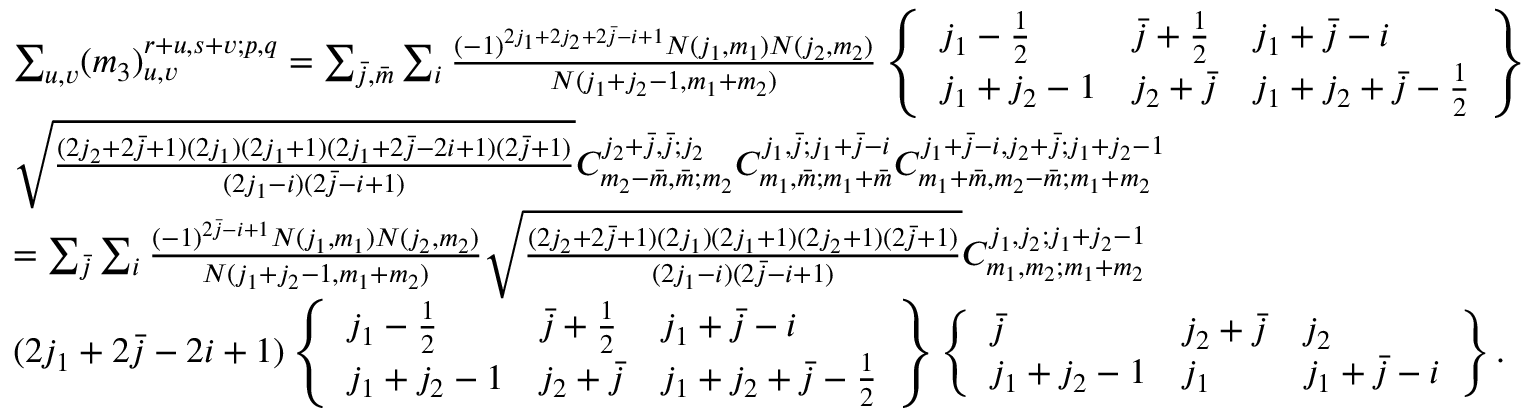Convert formula to latex. <formula><loc_0><loc_0><loc_500><loc_500>\begin{array} { r l } & { \sum _ { u , v } ( m _ { 3 } ) _ { u , v } ^ { r + u , s + v ; p , q } = \sum _ { \bar { j } , \bar { m } } \sum _ { i } \frac { ( - 1 ) ^ { 2 j _ { 1 } + 2 j _ { 2 } + 2 \bar { j } - i + 1 } N ( j _ { 1 } , m _ { 1 } ) N ( j _ { 2 } , m _ { 2 } ) } { N ( j _ { 1 } + j _ { 2 } - 1 , m _ { 1 } + m _ { 2 } ) } \left \{ \begin{array} { l l l } { j _ { 1 } - \frac { 1 } { 2 } } & { \bar { j } + \frac { 1 } { 2 } } & { j _ { 1 } + \bar { j } - i } \\ { j _ { 1 } + j _ { 2 } - 1 } & { j _ { 2 } + \bar { j } } & { j _ { 1 } + j _ { 2 } + \bar { j } - \frac { 1 } { 2 } } \end{array} \right \} } \\ & { \sqrt { \frac { ( 2 j _ { 2 } + 2 \bar { j } + 1 ) ( 2 j _ { 1 } ) ( 2 j _ { 1 } + 1 ) ( 2 j _ { 1 } + 2 \bar { j } - 2 i + 1 ) ( 2 \bar { j } + 1 ) } { ( 2 j _ { 1 } - i ) ( 2 \bar { j } - i + 1 ) } } C _ { m _ { 2 } - \bar { m } , \bar { m } ; m _ { 2 } } ^ { j _ { 2 } + \bar { j } , \bar { j } ; j _ { 2 } } C _ { m _ { 1 } , \bar { m } ; m _ { 1 } + \bar { m } } ^ { j _ { 1 } , \bar { j } ; j _ { 1 } + \bar { j } - i } C _ { m _ { 1 } + \bar { m } , m _ { 2 } - \bar { m } ; m _ { 1 } + m _ { 2 } } ^ { j _ { 1 } + \bar { j } - i , j _ { 2 } + \bar { j } ; j _ { 1 } + j _ { 2 } - 1 } } \\ & { = \sum _ { \bar { j } } \sum _ { i } \frac { ( - 1 ) ^ { 2 \bar { j } - i + 1 } N ( j _ { 1 } , m _ { 1 } ) N ( j _ { 2 } , m _ { 2 } ) } { N ( j _ { 1 } + j _ { 2 } - 1 , m _ { 1 } + m _ { 2 } ) } \sqrt { \frac { ( 2 j _ { 2 } + 2 \bar { j } + 1 ) ( 2 j _ { 1 } ) ( 2 j _ { 1 } + 1 ) ( 2 j _ { 2 } + 1 ) ( 2 \bar { j } + 1 ) } { ( 2 j _ { 1 } - i ) ( 2 \bar { j } - i + 1 ) } } C _ { m _ { 1 } , m _ { 2 } ; m _ { 1 } + m _ { 2 } } ^ { j _ { 1 } , j _ { 2 } ; j _ { 1 } + j _ { 2 } - 1 } } \\ & { ( 2 j _ { 1 } + 2 \bar { j } - 2 i + 1 ) \left \{ \begin{array} { l l l } { j _ { 1 } - \frac { 1 } { 2 } } & { \bar { j } + \frac { 1 } { 2 } } & { j _ { 1 } + \bar { j } - i } \\ { j _ { 1 } + j _ { 2 } - 1 } & { j _ { 2 } + \bar { j } } & { j _ { 1 } + j _ { 2 } + \bar { j } - \frac { 1 } { 2 } } \end{array} \right \} \left \{ \begin{array} { l l l } { \bar { j } } & { j _ { 2 } + \bar { j } } & { j _ { 2 } } \\ { j _ { 1 } + j _ { 2 } - 1 } & { j _ { 1 } } & { j _ { 1 } + \bar { j } - i } \end{array} \right \} . } \end{array}</formula> 